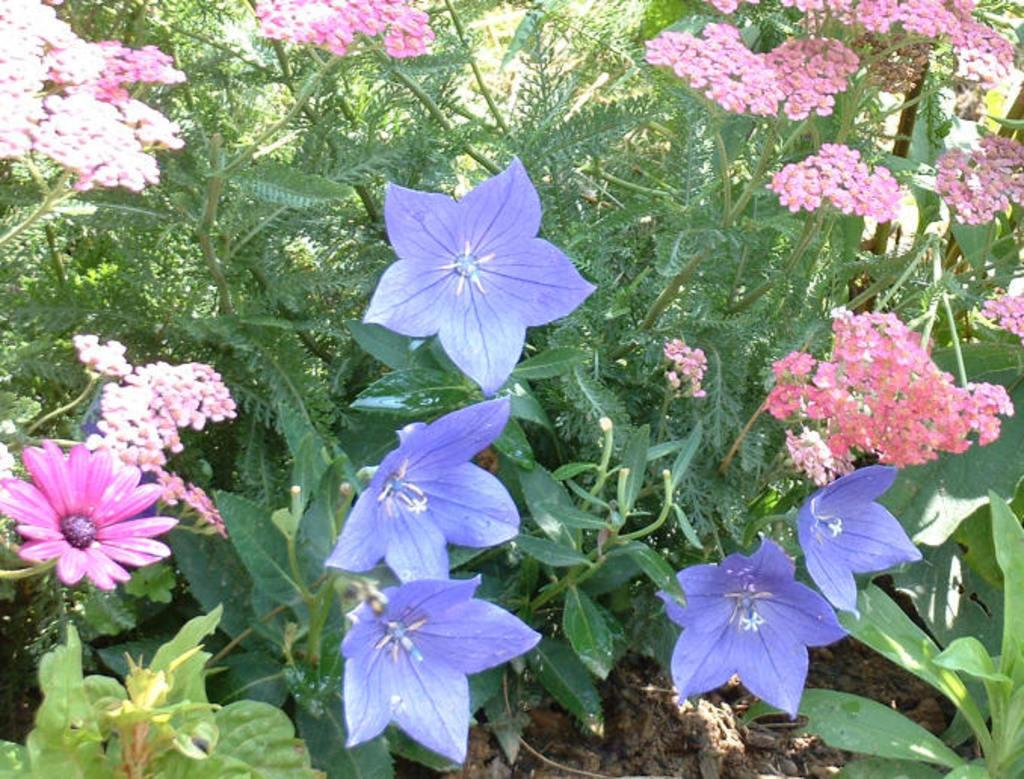What type of living organisms can be seen in the image? Plants can be seen in the image. Do the plants in the image have any specific features? Yes, the plants have flowers. What time of day is it in the image, and who is driving the car? The provided facts do not mention a car or a specific time of day, so it is not possible to answer those questions based on the information given. 